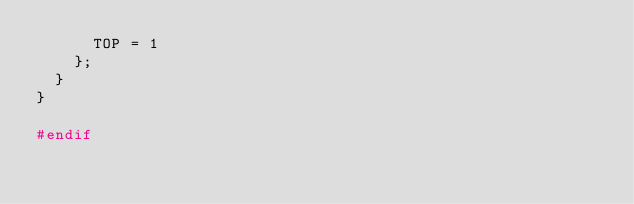Convert code to text. <code><loc_0><loc_0><loc_500><loc_500><_C_>			TOP = 1
		};
	}
}

#endif</code> 